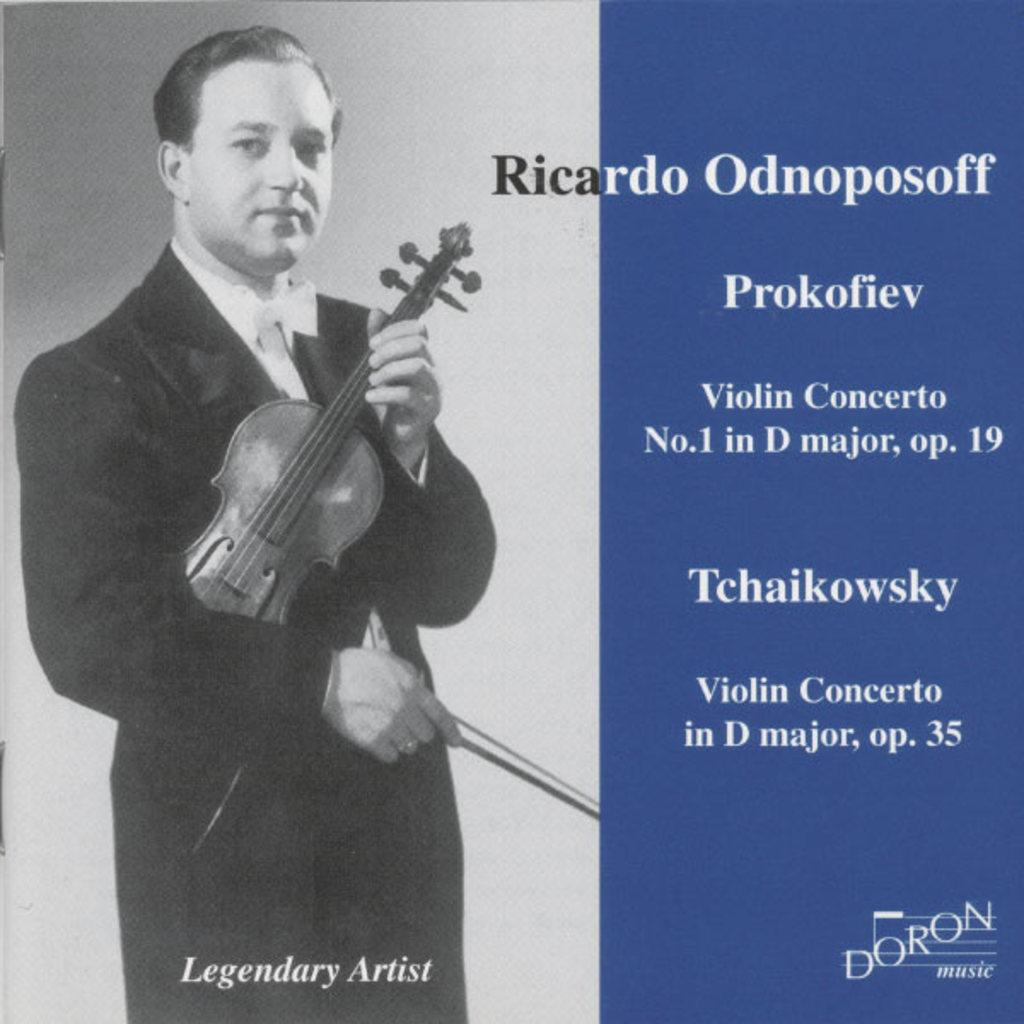What type of object is in the image? There is an old poster in the image. What is depicted on the poster? The poster features a person holding a violin. How is the person holding the violin? The person is holding the violin in his hand. What else can be seen on the poster besides the person and the violin? There is text written on the poster. What type of shade is covering the person holding the violin in the image? There is no shade covering the person holding the violin in the image; it is a poster with a person and a violin. 